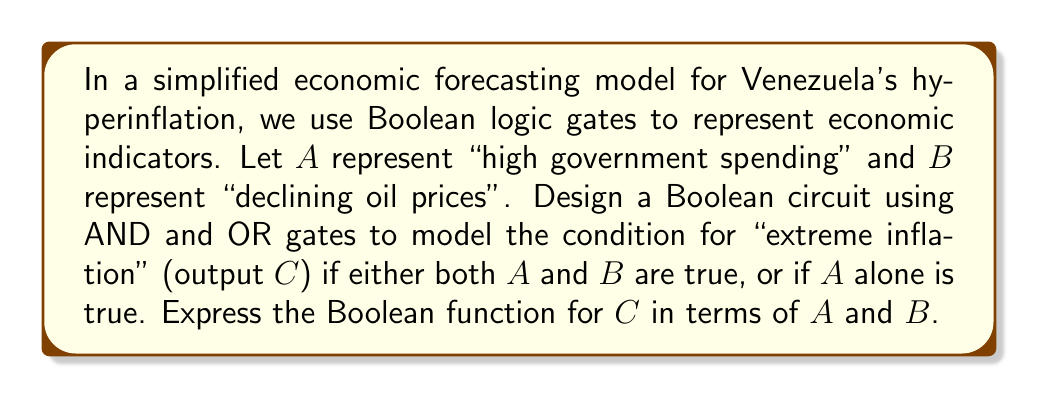Solve this math problem. Let's approach this step-by-step:

1) We need to create a Boolean function that outputs true (1) for "extreme inflation" (C) when:
   - Both A and B are true, OR
   - A is true (regardless of B)

2) We can represent this using Boolean algebra:
   $C = (A \cdot B) + A$

3) To implement this using logic gates:
   - We need an AND gate to represent $(A \cdot B)$
   - We need an OR gate to combine $(A \cdot B)$ with $A$

4) The circuit would look like this:

   [asy]
   import geometry;

   // Draw AND gate
   path and = (0,0)--(0,20)--(10,20)..tension 1.5..(20,10)..(10,0)--cycle;
   draw(and);
   label("AND", (10,10));

   // Draw OR gate
   path or = (50,0){up}..tension 1..(60,20){down}..{down}(70,0){up}..tension 1..(60,20);
   draw(or);
   label("OR", (60,10));

   // Draw inputs and output
   draw((-10,15)--(0,15));
   draw((-10,5)--(0,5));
   draw((20,10)--(50,15));
   draw((40,5)--(50,5));
   draw((70,10)--(80,10));

   // Label inputs and output
   label("A", (-12,15), E);
   label("B", (-12,5), E);
   label("A", (40,5), N);
   label("C", (82,10), W);
   [/asy]

5) The Boolean function $C = (A \cdot B) + A$ can be simplified:
   $C = (A \cdot B) + A$
   $C = A \cdot (B + 1)$  (using distributive property)
   $C = A$                (since $B + 1 = 1$ in Boolean algebra)

6) This simplification shows that in this model, "extreme inflation" (C) occurs whenever there is "high government spending" (A), regardless of oil prices (B).
Answer: $C = A$ 